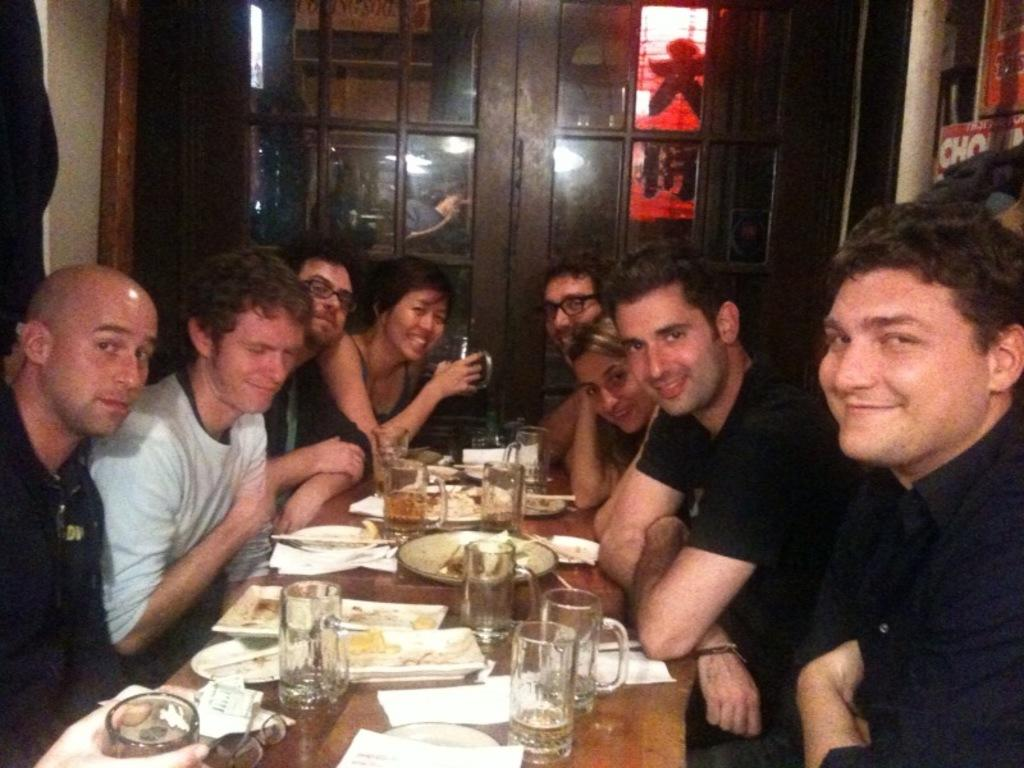What type of structure can be seen in the image? There is a wall in the image. Is there an entrance visible in the image? Yes, there is a door in the image. What are the people in the image doing? There is a group of people sitting on chairs in the image. What is on the table in the image? There are glasses, plates, and different types of dishes on the table. Are there any additional items on the table? Yes, there are tissues on the table. What type of transport can be seen in the image? There is no transport visible in the image. Is there a snake present in the image? No, there is no snake present in the image. 